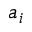<formula> <loc_0><loc_0><loc_500><loc_500>a _ { i }</formula> 